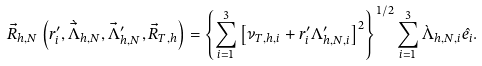Convert formula to latex. <formula><loc_0><loc_0><loc_500><loc_500>\vec { R } _ { h , N } \left ( r ^ { \prime } _ { i } , \grave { \vec { \Lambda } } _ { h , N } , \vec { \Lambda } ^ { \prime } _ { h , N } , \vec { R } _ { T , h } \right ) & = \left \{ \sum _ { i = 1 } ^ { 3 } \left [ \nu _ { T , h , i } + r ^ { \prime } _ { i } \Lambda ^ { \prime } _ { h , N , i } \right ] ^ { 2 } \right \} ^ { 1 / 2 } \sum _ { i = 1 } ^ { 3 } \grave { \Lambda } _ { h , N , i } \hat { e _ { i } } .</formula> 